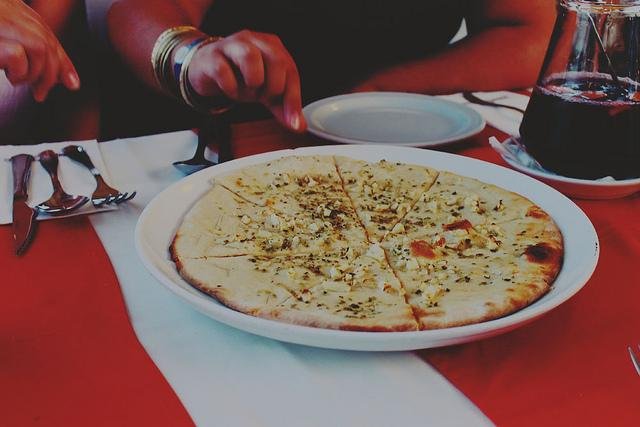What can one of the shiny silver things do?

Choices:
A) cut
B) generate electricity
C) drive
D) compute cut 